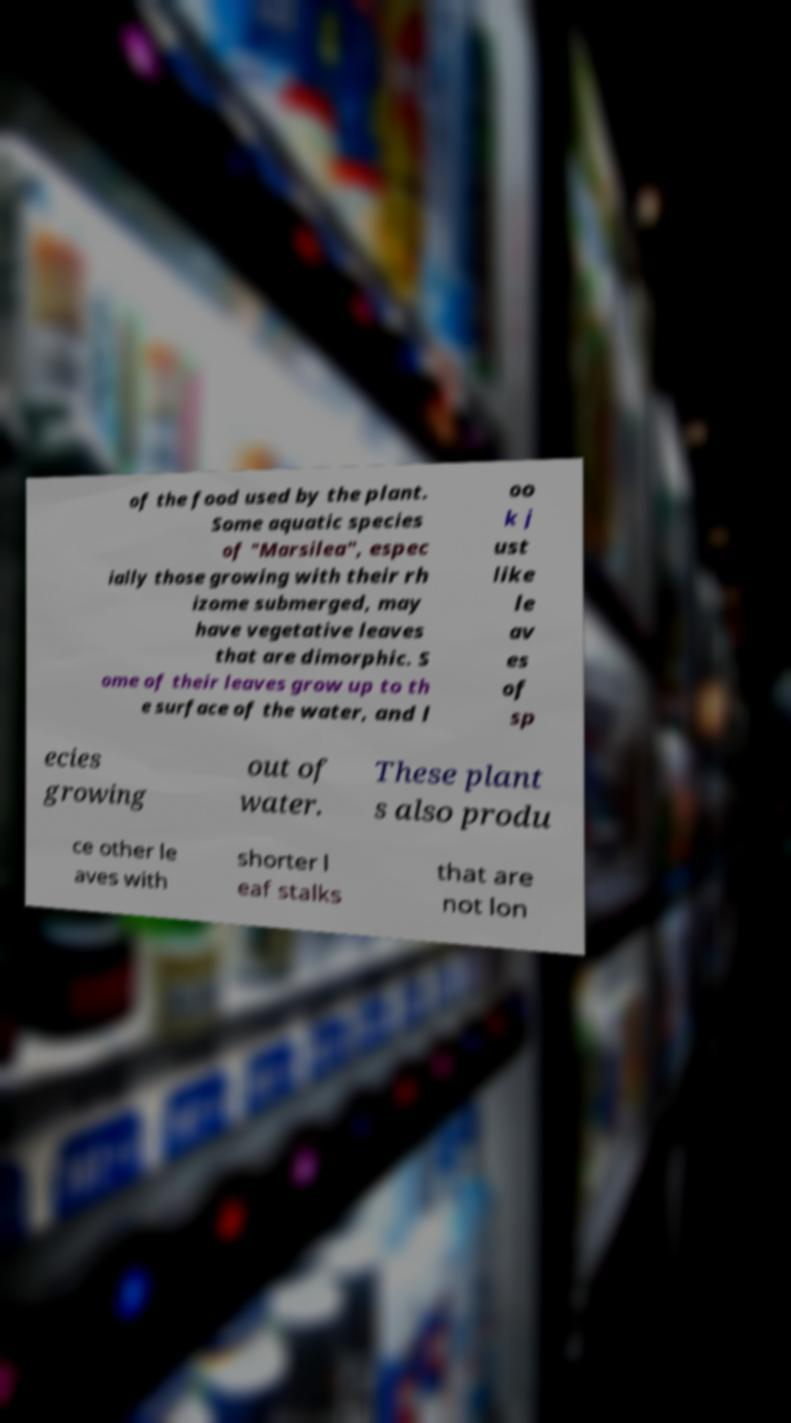What messages or text are displayed in this image? I need them in a readable, typed format. of the food used by the plant. Some aquatic species of "Marsilea", espec ially those growing with their rh izome submerged, may have vegetative leaves that are dimorphic. S ome of their leaves grow up to th e surface of the water, and l oo k j ust like le av es of sp ecies growing out of water. These plant s also produ ce other le aves with shorter l eaf stalks that are not lon 